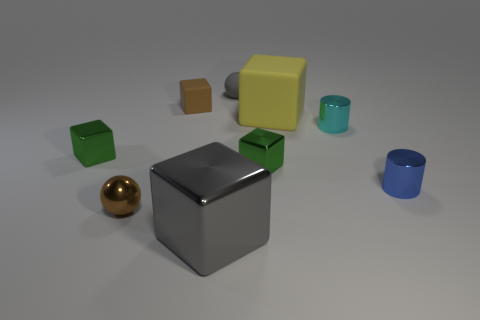Subtract all gray balls. How many green cubes are left? 2 Subtract all green cubes. How many cubes are left? 3 Subtract 1 cubes. How many cubes are left? 4 Add 1 small brown spheres. How many objects exist? 10 Subtract all yellow cubes. How many cubes are left? 4 Subtract all cylinders. How many objects are left? 7 Subtract all brown cubes. Subtract all purple cylinders. How many cubes are left? 4 Subtract all big gray metal cubes. Subtract all yellow rubber spheres. How many objects are left? 8 Add 2 yellow things. How many yellow things are left? 3 Add 2 tiny cyan metallic things. How many tiny cyan metallic things exist? 3 